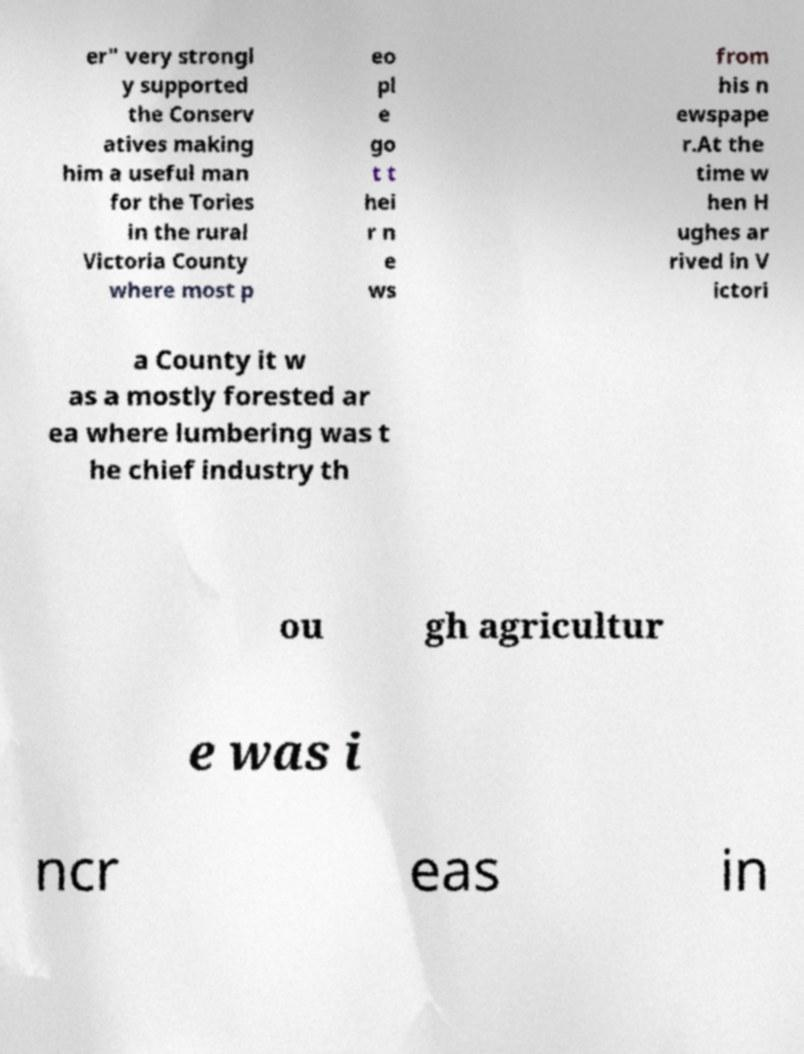What messages or text are displayed in this image? I need them in a readable, typed format. er" very strongl y supported the Conserv atives making him a useful man for the Tories in the rural Victoria County where most p eo pl e go t t hei r n e ws from his n ewspape r.At the time w hen H ughes ar rived in V ictori a County it w as a mostly forested ar ea where lumbering was t he chief industry th ou gh agricultur e was i ncr eas in 